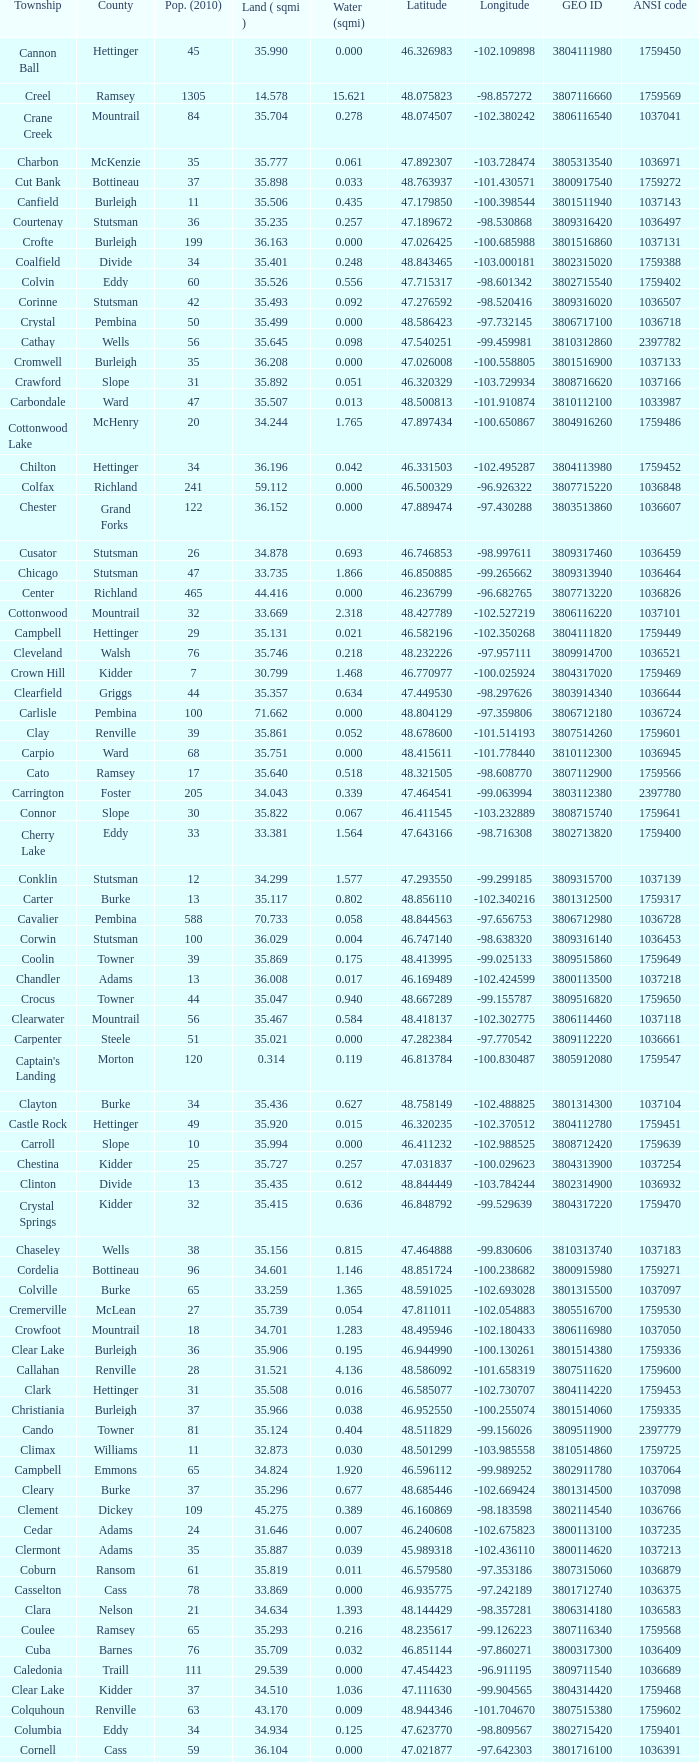What was the latitude of the Clearwater townsship? 48.418137. 